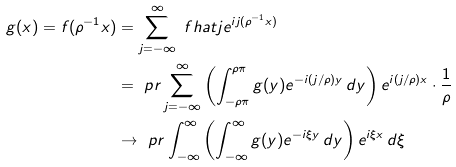<formula> <loc_0><loc_0><loc_500><loc_500>g ( x ) = f ( \rho ^ { - 1 } x ) & = \sum _ { j = - \infty } ^ { \infty } \ f h a t j e ^ { i j ( \rho ^ { - 1 } x ) } \\ & = \ p r \sum _ { j = - \infty } ^ { \infty } \left ( \int _ { - \rho \pi } ^ { \rho \pi } g ( y ) e ^ { - i ( j / \rho ) y } \, d y \right ) e ^ { i ( j / \rho ) x } \cdot \frac { 1 } { \rho } \\ & \to \ p r \int _ { - \infty } ^ { \infty } \left ( \int _ { - \infty } ^ { \infty } g ( y ) e ^ { - i \xi y } \, d y \right ) e ^ { i \xi x } \, d \xi</formula> 